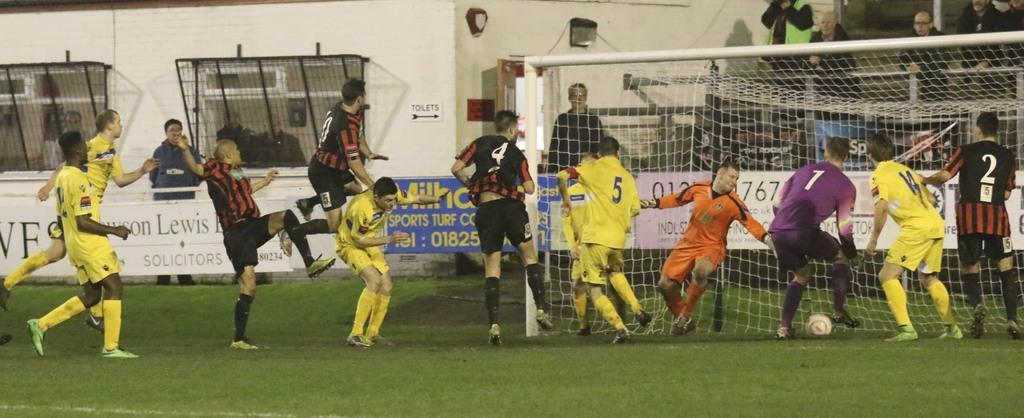<image>
Provide a brief description of the given image. Player number 1 in a purple jersey is about to kick the ball into the goal. 